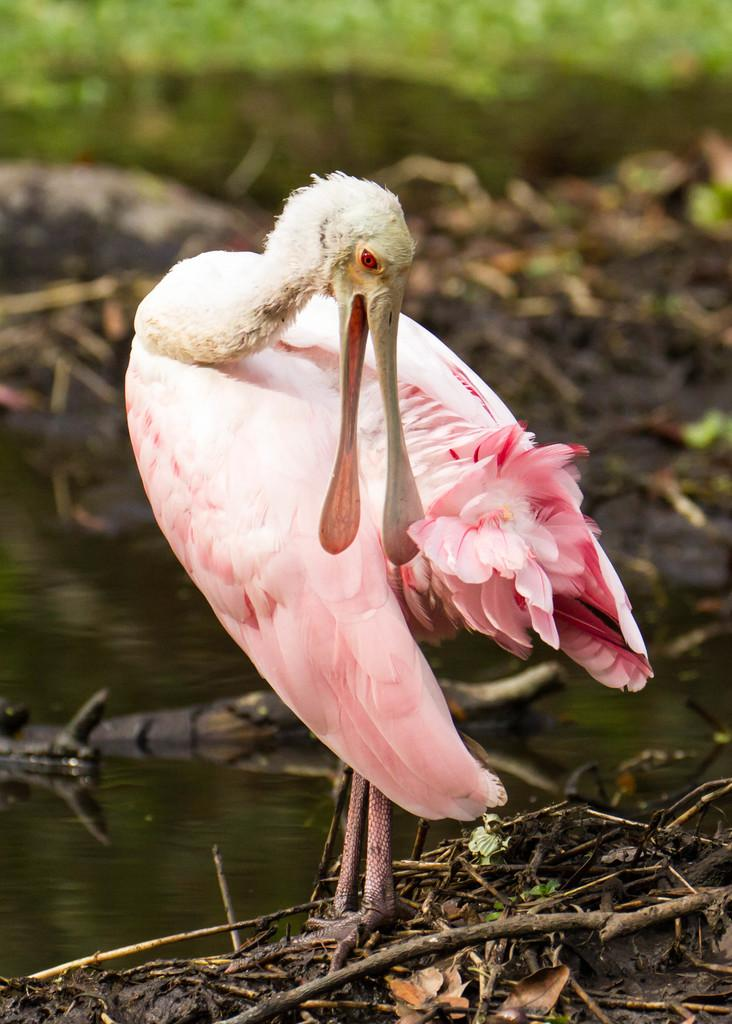What type of bird can be seen in the image? There is a bird named spoonbill in the image. What is the bird doing in the image? The bird is standing in the image. What can be seen in the background of the image? There appears to be water flowing and stems and branches visible in the image. How would you describe the clarity of the background in the image? The background of the image is blurry. What type of lunch does the spoonbill bird's grandmother prepare for her in the image? There is no mention of a grandmother or lunch in the image; it only features a spoonbill bird standing near water and vegetation. 